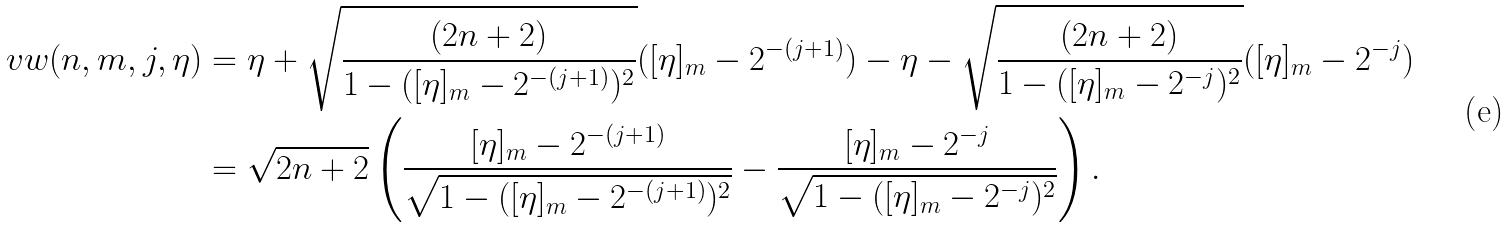<formula> <loc_0><loc_0><loc_500><loc_500>v w ( n , m , j , \eta ) & = \eta + \sqrt { \frac { ( 2 n + 2 ) } { 1 - ( [ \eta ] _ { m } - 2 ^ { - ( j + 1 ) } ) ^ { 2 } } } ( [ \eta ] _ { m } - 2 ^ { - ( j + 1 ) } ) - \eta - \sqrt { \frac { ( 2 n + 2 ) } { 1 - ( [ \eta ] _ { m } - 2 ^ { - j } ) ^ { 2 } } } ( [ \eta ] _ { m } - 2 ^ { - j } ) \\ & = \sqrt { 2 n + 2 } \left ( \frac { [ \eta ] _ { m } - 2 ^ { - ( j + 1 ) } } { \sqrt { 1 - ( [ \eta ] _ { m } - 2 ^ { - ( j + 1 ) } ) ^ { 2 } } } - \frac { [ \eta ] _ { m } - 2 ^ { - j } } { \sqrt { 1 - ( [ \eta ] _ { m } - 2 ^ { - j } ) ^ { 2 } } } \right ) .</formula> 